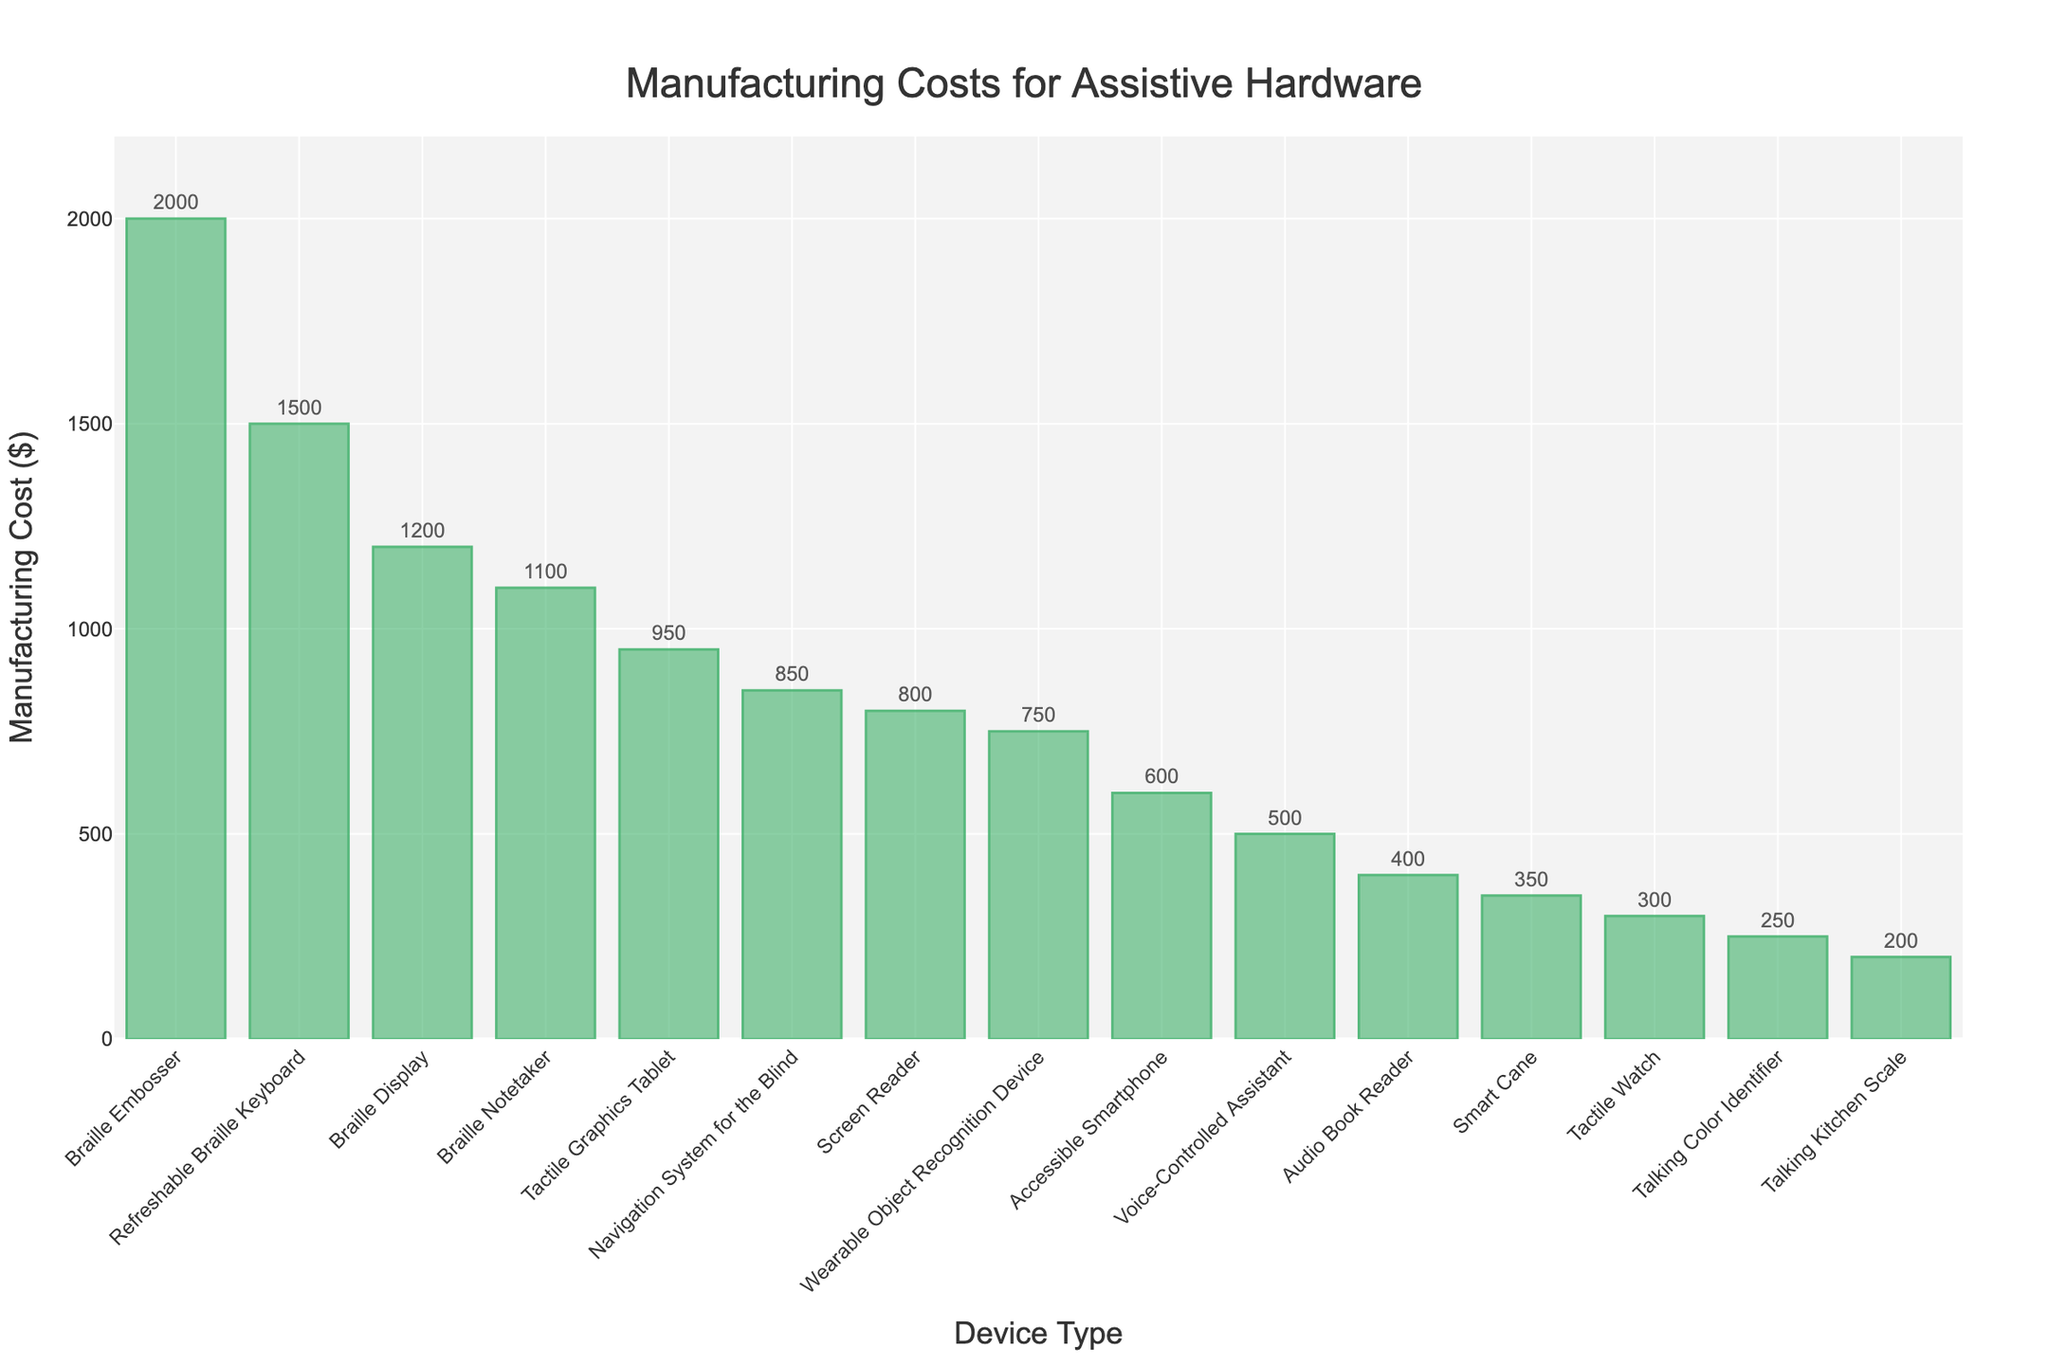Which device has the highest manufacturing cost? By examining the bar chart, the highest bar represents the device with the highest manufacturing cost.
Answer: Braille Embosser What is the manufacturing cost difference between the screen reader and the smart cane? Identify the bars for "Screen Reader" and "Smart Cane" and subtract their heights to find the difference. Screen Reader costs $800, and Smart Cane costs $350, so the difference is $800 - $350.
Answer: $450 Which device has a lower manufacturing cost, the Audio Book Reader or the Tactile Watch? Compare the heights of the bars for "Audio Book Reader" and "Tactile Watch". The bar representing the "Tactile Watch" is lower.
Answer: Tactile Watch What is the average manufacturing cost of the following devices: Braille Display, Voice-Controlled Assistant, and Talking Color Identifier? Sum the costs of the Braille Display ($1200), Voice-Controlled Assistant ($500), and Talking Color Identifier ($250), then divide by the number of devices (3). (1200 + 500 + 250) / 3 = 1950 / 3.
Answer: $650 Which devices have manufacturing costs greater than $1000? Look for bars where the height is higher than $1000 and list the corresponding devices. The devices are Braille Display ($1200), Refreshable Braille Keyboard ($1500), Braille Notetaker ($1100), and Braille Embosser ($2000).
Answer: Braille Display, Refreshable Braille Keyboard, Braille Notetaker, Braille Embosser What is the median manufacturing cost of all the devices? First, order all manufacturing costs: $200, $250, $300, $350, $400, $500, $600, $750, $800, $850, $950, $1100, $1200, $1500, $2000. The median is the middle value, which is the 8th value in this ordered list.
Answer: $750 Which two devices have the smallest manufacturing cost, and what are their costs? Identify the two shortest bars in the chart. The devices are the Talking Kitchen Scale ($200) and the Talking Color Identifier ($250).
Answer: Talking Kitchen Scale ($200), Talking Color Identifier ($250) Is the manufacturing cost of the Accessible Smartphone greater than the cost of the Wearable Object Recognition Device? Compare the heights of the bars corresponding to the Accessible Smartphone ($600) and Wearable Object Recognition Device ($750). The Accessible Smartphone's bar is lower.
Answer: No Calculate the total manufacturing cost of the five least expensive devices. Identify the five smallest bars: Talking Kitchen Scale ($200), Talking Color Identifier ($250), Tactile Watch ($300), Smart Cane ($350), Audio Book Reader ($400). Sum their costs: $200 + $250 + $300 + $350 + $400.
Answer: $1500 How much more expensive is the Refreshable Braille Keyboard to manufacture than the Tactile Graphics Tablet? Subtract the manufacturing cost of the Tactile Graphics Tablet ($950) from the cost of the Refreshable Braille Keyboard ($1500).
Answer: $550 